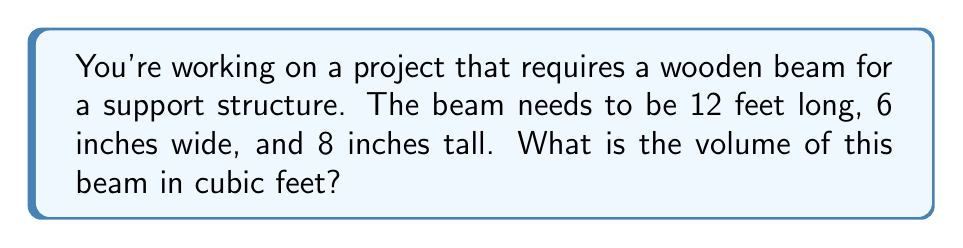Solve this math problem. To find the volume of a rectangular beam, we need to multiply its length, width, and height. However, we need to make sure all measurements are in the same unit (in this case, feet) before we multiply.

Let's convert the dimensions to feet:
1. Length: 12 feet (already in feet)
2. Width: 6 inches = 6 ÷ 12 = 0.5 feet (since there are 12 inches in a foot)
3. Height: 8 inches = 8 ÷ 12 ≈ 0.6667 feet

Now we can calculate the volume using the formula:

$$ V = l \times w \times h $$

Where:
$V$ = volume
$l$ = length
$w$ = width
$h$ = height

Plugging in our values:

$$ V = 12 \times 0.5 \times 0.6667 $$

$$ V = 4 \text{ cubic feet} $$

So, the volume of the beam is 4 cubic feet.
Answer: 4 cubic feet 